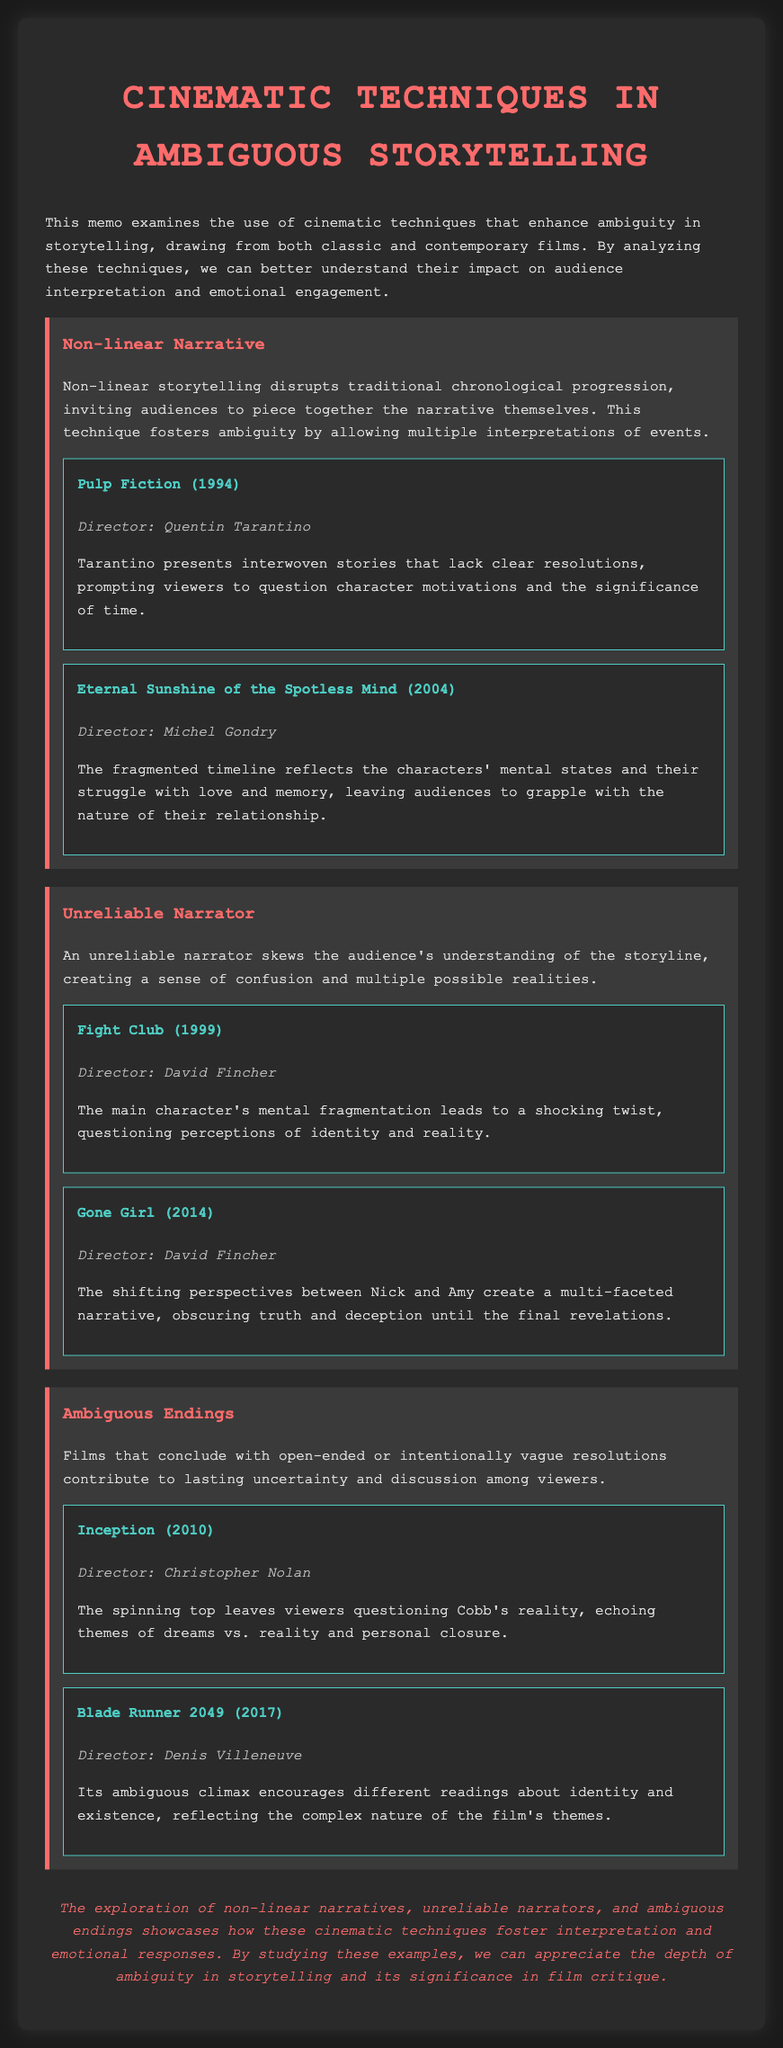what cinematic technique disrupts traditional chronological progression? The technique that disrupts this progression is non-linear storytelling, which invites audiences to piece together the narrative themselves.
Answer: Non-linear Narrative who directed Pulp Fiction? The director of Pulp Fiction is Quentin Tarantino.
Answer: Quentin Tarantino what year was Eternal Sunshine of the Spotless Mind released? Eternal Sunshine of the Spotless Mind was released in 2004.
Answer: 2004 which film features a shocking twist questioning perceptions of identity? The film that features this shocking twist is Fight Club.
Answer: Fight Club what theme does the ambiguous ending of Inception echo? The ambiguous ending echoes the themes of dreams vs. reality and personal closure.
Answer: Dreams vs. reality how does Blade Runner 2049 encourage different readings? Blade Runner 2049 encourages different readings through its ambiguous climax, reflecting complex themes.
Answer: Ambiguous climax what does an unreliable narrator create in the storytelling? An unreliable narrator creates confusion and multiple possible realities for the audience.
Answer: Confusion what is the color of the heading for the film examples? The color of the heading for the film examples is #4ecdc4.
Answer: #4ecdc4 